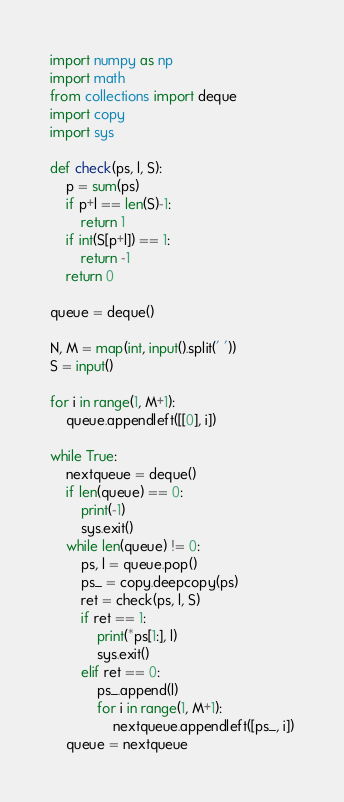Convert code to text. <code><loc_0><loc_0><loc_500><loc_500><_Python_>import numpy as np
import math
from collections import deque
import copy
import sys

def check(ps, l, S):
    p = sum(ps)
    if p+l == len(S)-1:
        return 1
    if int(S[p+l]) == 1:
        return -1
    return 0

queue = deque()

N, M = map(int, input().split(' '))
S = input()

for i in range(1, M+1):
    queue.appendleft([[0], i])

while True:
    nextqueue = deque()
    if len(queue) == 0:
        print(-1)
        sys.exit()
    while len(queue) != 0:
        ps, l = queue.pop()
        ps_ = copy.deepcopy(ps)
        ret = check(ps, l, S)
        if ret == 1:
            print(*ps[1:], l)
            sys.exit()
        elif ret == 0:
            ps_.append(l)
            for i in range(1, M+1):
                nextqueue.appendleft([ps_, i])
    queue = nextqueue
</code> 